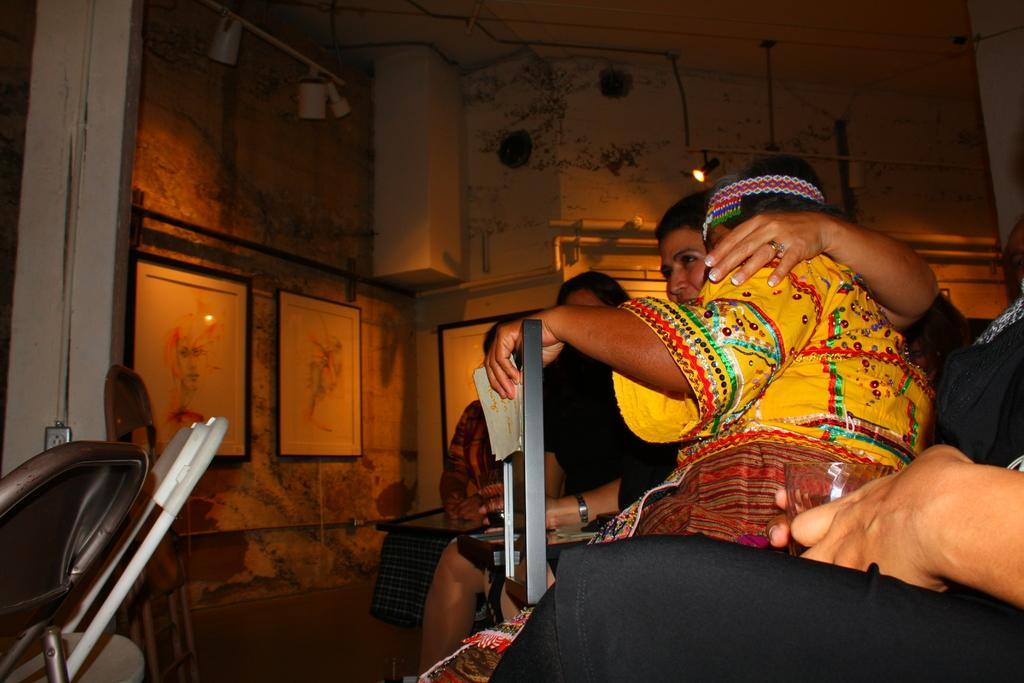Could you give a brief overview of what you see in this image? In this picture there is a woman who is wearing yellow dress. Beside her we can see another woman who is wearing black dress. At the bottom there is a person's leg. In the background we can see paintings on the wall. At the top there is a duct and cable. In the bottom left corner we can see the socket, chairs and pillar. 